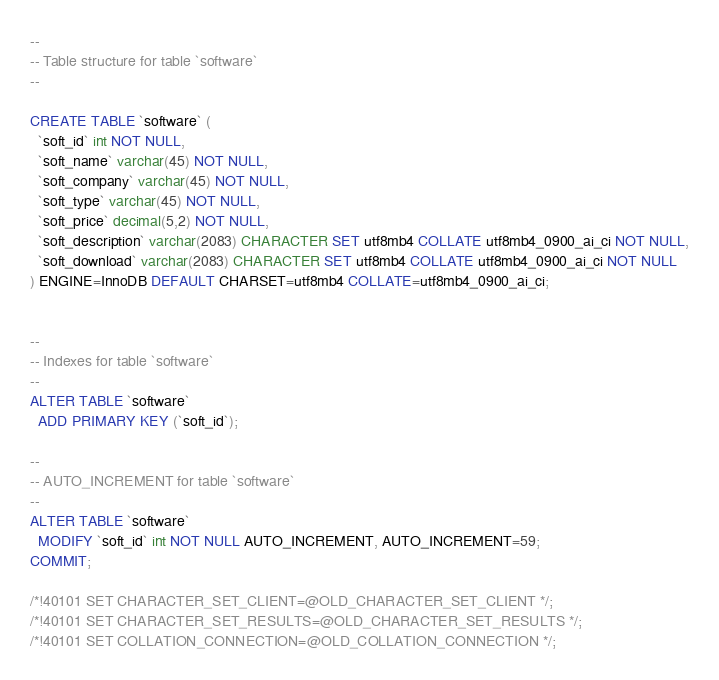<code> <loc_0><loc_0><loc_500><loc_500><_SQL_>

--
-- Table structure for table `software`
--

CREATE TABLE `software` (
  `soft_id` int NOT NULL,
  `soft_name` varchar(45) NOT NULL,
  `soft_company` varchar(45) NOT NULL,
  `soft_type` varchar(45) NOT NULL,
  `soft_price` decimal(5,2) NOT NULL,
  `soft_description` varchar(2083) CHARACTER SET utf8mb4 COLLATE utf8mb4_0900_ai_ci NOT NULL,
  `soft_download` varchar(2083) CHARACTER SET utf8mb4 COLLATE utf8mb4_0900_ai_ci NOT NULL
) ENGINE=InnoDB DEFAULT CHARSET=utf8mb4 COLLATE=utf8mb4_0900_ai_ci;


--
-- Indexes for table `software`
--
ALTER TABLE `software`
  ADD PRIMARY KEY (`soft_id`);

--
-- AUTO_INCREMENT for table `software`
--
ALTER TABLE `software`
  MODIFY `soft_id` int NOT NULL AUTO_INCREMENT, AUTO_INCREMENT=59;
COMMIT;

/*!40101 SET CHARACTER_SET_CLIENT=@OLD_CHARACTER_SET_CLIENT */;
/*!40101 SET CHARACTER_SET_RESULTS=@OLD_CHARACTER_SET_RESULTS */;
/*!40101 SET COLLATION_CONNECTION=@OLD_COLLATION_CONNECTION */;
</code> 